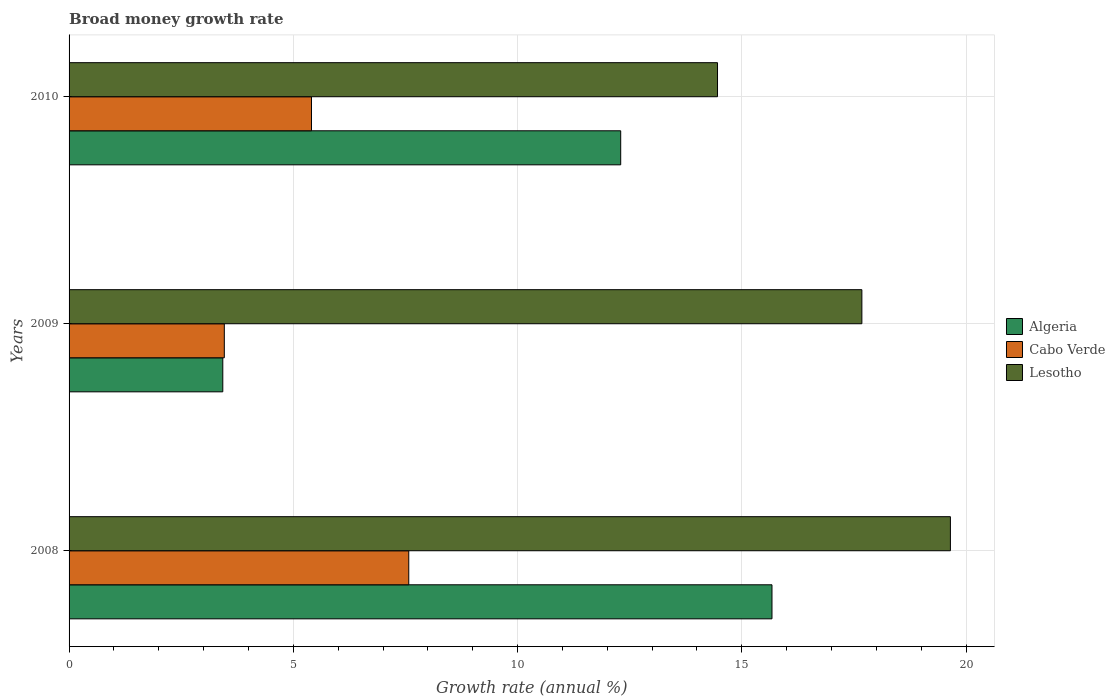How many different coloured bars are there?
Give a very brief answer. 3. Are the number of bars per tick equal to the number of legend labels?
Provide a short and direct response. Yes. Are the number of bars on each tick of the Y-axis equal?
Your answer should be very brief. Yes. How many bars are there on the 2nd tick from the top?
Provide a short and direct response. 3. How many bars are there on the 1st tick from the bottom?
Provide a succinct answer. 3. What is the growth rate in Cabo Verde in 2010?
Make the answer very short. 5.41. Across all years, what is the maximum growth rate in Lesotho?
Make the answer very short. 19.65. Across all years, what is the minimum growth rate in Lesotho?
Give a very brief answer. 14.46. In which year was the growth rate in Lesotho maximum?
Offer a terse response. 2008. In which year was the growth rate in Algeria minimum?
Make the answer very short. 2009. What is the total growth rate in Lesotho in the graph?
Your response must be concise. 51.79. What is the difference between the growth rate in Algeria in 2009 and that in 2010?
Your answer should be compact. -8.87. What is the difference between the growth rate in Algeria in 2010 and the growth rate in Cabo Verde in 2008?
Offer a terse response. 4.73. What is the average growth rate in Cabo Verde per year?
Offer a very short reply. 5.48. In the year 2008, what is the difference between the growth rate in Lesotho and growth rate in Algeria?
Offer a very short reply. 3.98. In how many years, is the growth rate in Cabo Verde greater than 7 %?
Make the answer very short. 1. What is the ratio of the growth rate in Algeria in 2008 to that in 2010?
Offer a terse response. 1.27. What is the difference between the highest and the second highest growth rate in Lesotho?
Make the answer very short. 1.97. What is the difference between the highest and the lowest growth rate in Algeria?
Provide a succinct answer. 12.25. Is the sum of the growth rate in Algeria in 2008 and 2010 greater than the maximum growth rate in Lesotho across all years?
Your response must be concise. Yes. What does the 3rd bar from the top in 2008 represents?
Your answer should be compact. Algeria. What does the 1st bar from the bottom in 2009 represents?
Provide a short and direct response. Algeria. Is it the case that in every year, the sum of the growth rate in Algeria and growth rate in Lesotho is greater than the growth rate in Cabo Verde?
Provide a short and direct response. Yes. How many bars are there?
Ensure brevity in your answer.  9. Are all the bars in the graph horizontal?
Keep it short and to the point. Yes. Where does the legend appear in the graph?
Your answer should be compact. Center right. How many legend labels are there?
Your answer should be very brief. 3. How are the legend labels stacked?
Give a very brief answer. Vertical. What is the title of the graph?
Ensure brevity in your answer.  Broad money growth rate. What is the label or title of the X-axis?
Your response must be concise. Growth rate (annual %). What is the label or title of the Y-axis?
Provide a succinct answer. Years. What is the Growth rate (annual %) in Algeria in 2008?
Your response must be concise. 15.67. What is the Growth rate (annual %) of Cabo Verde in 2008?
Make the answer very short. 7.57. What is the Growth rate (annual %) of Lesotho in 2008?
Your response must be concise. 19.65. What is the Growth rate (annual %) of Algeria in 2009?
Provide a succinct answer. 3.43. What is the Growth rate (annual %) in Cabo Verde in 2009?
Offer a terse response. 3.46. What is the Growth rate (annual %) in Lesotho in 2009?
Your answer should be compact. 17.68. What is the Growth rate (annual %) in Algeria in 2010?
Your answer should be compact. 12.3. What is the Growth rate (annual %) of Cabo Verde in 2010?
Make the answer very short. 5.41. What is the Growth rate (annual %) of Lesotho in 2010?
Make the answer very short. 14.46. Across all years, what is the maximum Growth rate (annual %) in Algeria?
Offer a very short reply. 15.67. Across all years, what is the maximum Growth rate (annual %) of Cabo Verde?
Your answer should be compact. 7.57. Across all years, what is the maximum Growth rate (annual %) of Lesotho?
Ensure brevity in your answer.  19.65. Across all years, what is the minimum Growth rate (annual %) of Algeria?
Provide a short and direct response. 3.43. Across all years, what is the minimum Growth rate (annual %) in Cabo Verde?
Offer a terse response. 3.46. Across all years, what is the minimum Growth rate (annual %) of Lesotho?
Your answer should be compact. 14.46. What is the total Growth rate (annual %) in Algeria in the graph?
Provide a succinct answer. 31.4. What is the total Growth rate (annual %) of Cabo Verde in the graph?
Make the answer very short. 16.44. What is the total Growth rate (annual %) in Lesotho in the graph?
Offer a terse response. 51.79. What is the difference between the Growth rate (annual %) in Algeria in 2008 and that in 2009?
Your answer should be very brief. 12.25. What is the difference between the Growth rate (annual %) of Cabo Verde in 2008 and that in 2009?
Offer a terse response. 4.11. What is the difference between the Growth rate (annual %) in Lesotho in 2008 and that in 2009?
Offer a terse response. 1.97. What is the difference between the Growth rate (annual %) in Algeria in 2008 and that in 2010?
Offer a very short reply. 3.37. What is the difference between the Growth rate (annual %) in Cabo Verde in 2008 and that in 2010?
Your answer should be compact. 2.17. What is the difference between the Growth rate (annual %) of Lesotho in 2008 and that in 2010?
Keep it short and to the point. 5.19. What is the difference between the Growth rate (annual %) of Algeria in 2009 and that in 2010?
Your answer should be very brief. -8.87. What is the difference between the Growth rate (annual %) in Cabo Verde in 2009 and that in 2010?
Make the answer very short. -1.94. What is the difference between the Growth rate (annual %) in Lesotho in 2009 and that in 2010?
Give a very brief answer. 3.22. What is the difference between the Growth rate (annual %) in Algeria in 2008 and the Growth rate (annual %) in Cabo Verde in 2009?
Give a very brief answer. 12.21. What is the difference between the Growth rate (annual %) of Algeria in 2008 and the Growth rate (annual %) of Lesotho in 2009?
Give a very brief answer. -2. What is the difference between the Growth rate (annual %) in Cabo Verde in 2008 and the Growth rate (annual %) in Lesotho in 2009?
Keep it short and to the point. -10.1. What is the difference between the Growth rate (annual %) in Algeria in 2008 and the Growth rate (annual %) in Cabo Verde in 2010?
Your response must be concise. 10.27. What is the difference between the Growth rate (annual %) in Algeria in 2008 and the Growth rate (annual %) in Lesotho in 2010?
Provide a succinct answer. 1.21. What is the difference between the Growth rate (annual %) of Cabo Verde in 2008 and the Growth rate (annual %) of Lesotho in 2010?
Your answer should be very brief. -6.88. What is the difference between the Growth rate (annual %) in Algeria in 2009 and the Growth rate (annual %) in Cabo Verde in 2010?
Offer a terse response. -1.98. What is the difference between the Growth rate (annual %) in Algeria in 2009 and the Growth rate (annual %) in Lesotho in 2010?
Your response must be concise. -11.03. What is the difference between the Growth rate (annual %) of Cabo Verde in 2009 and the Growth rate (annual %) of Lesotho in 2010?
Give a very brief answer. -11. What is the average Growth rate (annual %) in Algeria per year?
Provide a succinct answer. 10.47. What is the average Growth rate (annual %) in Cabo Verde per year?
Ensure brevity in your answer.  5.48. What is the average Growth rate (annual %) in Lesotho per year?
Ensure brevity in your answer.  17.26. In the year 2008, what is the difference between the Growth rate (annual %) in Algeria and Growth rate (annual %) in Cabo Verde?
Your answer should be compact. 8.1. In the year 2008, what is the difference between the Growth rate (annual %) in Algeria and Growth rate (annual %) in Lesotho?
Your answer should be compact. -3.98. In the year 2008, what is the difference between the Growth rate (annual %) in Cabo Verde and Growth rate (annual %) in Lesotho?
Offer a very short reply. -12.08. In the year 2009, what is the difference between the Growth rate (annual %) in Algeria and Growth rate (annual %) in Cabo Verde?
Give a very brief answer. -0.03. In the year 2009, what is the difference between the Growth rate (annual %) in Algeria and Growth rate (annual %) in Lesotho?
Your response must be concise. -14.25. In the year 2009, what is the difference between the Growth rate (annual %) in Cabo Verde and Growth rate (annual %) in Lesotho?
Provide a short and direct response. -14.22. In the year 2010, what is the difference between the Growth rate (annual %) in Algeria and Growth rate (annual %) in Cabo Verde?
Make the answer very short. 6.89. In the year 2010, what is the difference between the Growth rate (annual %) in Algeria and Growth rate (annual %) in Lesotho?
Your response must be concise. -2.16. In the year 2010, what is the difference between the Growth rate (annual %) in Cabo Verde and Growth rate (annual %) in Lesotho?
Your answer should be very brief. -9.05. What is the ratio of the Growth rate (annual %) in Algeria in 2008 to that in 2009?
Provide a succinct answer. 4.57. What is the ratio of the Growth rate (annual %) in Cabo Verde in 2008 to that in 2009?
Provide a succinct answer. 2.19. What is the ratio of the Growth rate (annual %) in Lesotho in 2008 to that in 2009?
Keep it short and to the point. 1.11. What is the ratio of the Growth rate (annual %) in Algeria in 2008 to that in 2010?
Make the answer very short. 1.27. What is the ratio of the Growth rate (annual %) of Cabo Verde in 2008 to that in 2010?
Keep it short and to the point. 1.4. What is the ratio of the Growth rate (annual %) of Lesotho in 2008 to that in 2010?
Provide a succinct answer. 1.36. What is the ratio of the Growth rate (annual %) in Algeria in 2009 to that in 2010?
Offer a very short reply. 0.28. What is the ratio of the Growth rate (annual %) of Cabo Verde in 2009 to that in 2010?
Your response must be concise. 0.64. What is the ratio of the Growth rate (annual %) of Lesotho in 2009 to that in 2010?
Offer a terse response. 1.22. What is the difference between the highest and the second highest Growth rate (annual %) in Algeria?
Give a very brief answer. 3.37. What is the difference between the highest and the second highest Growth rate (annual %) of Cabo Verde?
Provide a short and direct response. 2.17. What is the difference between the highest and the second highest Growth rate (annual %) in Lesotho?
Give a very brief answer. 1.97. What is the difference between the highest and the lowest Growth rate (annual %) of Algeria?
Your answer should be compact. 12.25. What is the difference between the highest and the lowest Growth rate (annual %) of Cabo Verde?
Offer a very short reply. 4.11. What is the difference between the highest and the lowest Growth rate (annual %) in Lesotho?
Offer a terse response. 5.19. 